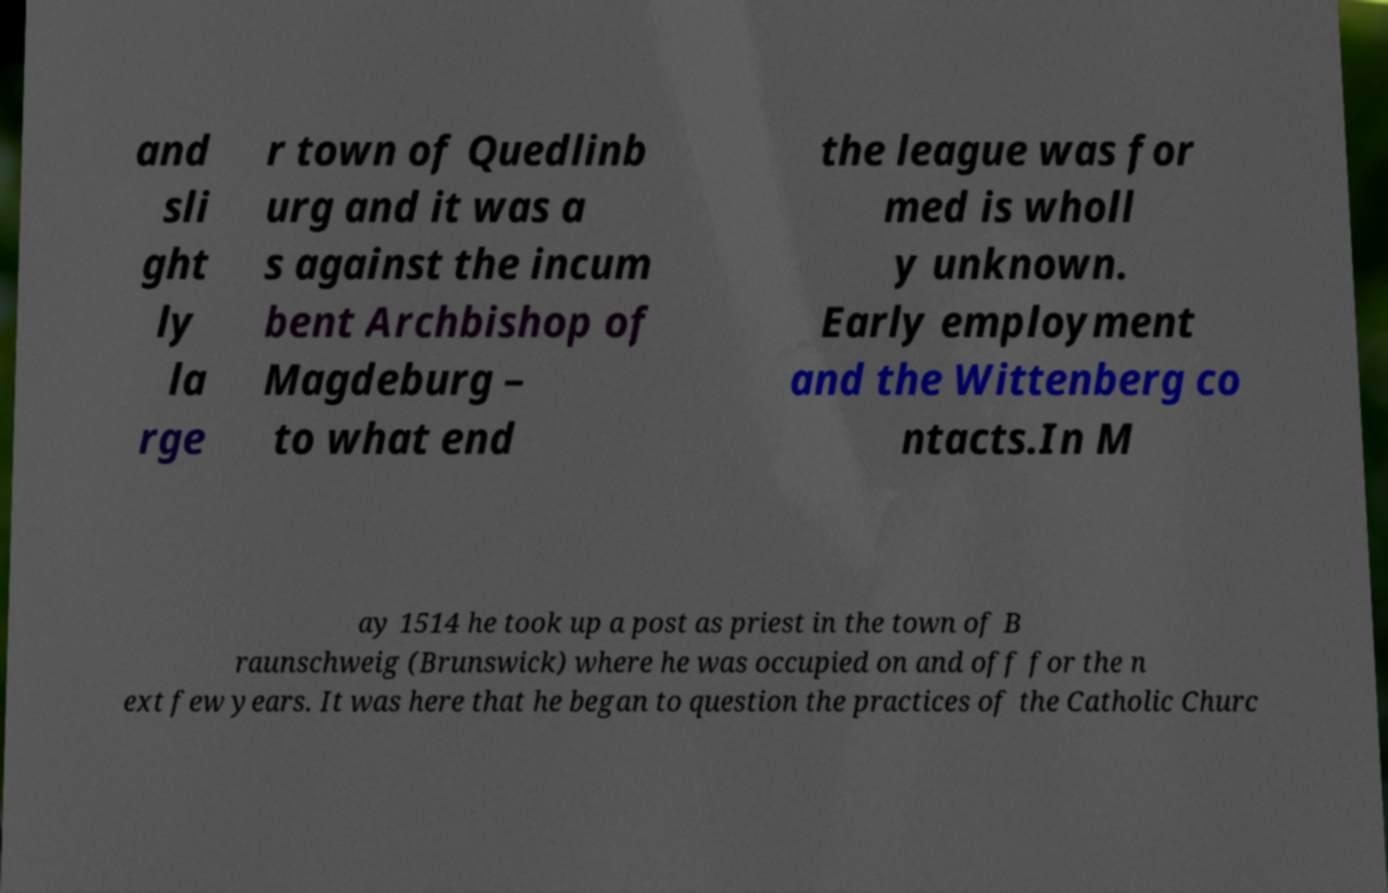Could you extract and type out the text from this image? and sli ght ly la rge r town of Quedlinb urg and it was a s against the incum bent Archbishop of Magdeburg – to what end the league was for med is wholl y unknown. Early employment and the Wittenberg co ntacts.In M ay 1514 he took up a post as priest in the town of B raunschweig (Brunswick) where he was occupied on and off for the n ext few years. It was here that he began to question the practices of the Catholic Churc 